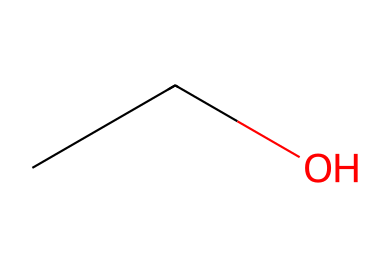How many carbon atoms are in this chemical? The SMILES representation "CCO" indicates the presence of two 'C' atoms, which are the carbon atoms in the chemical.
Answer: 2 What type of functional group is present in this chemical? The structure "CCO" shows that there is an -OH (hydroxyl) group present on one of the carbon atoms, identifying this chemical as an alcohol.
Answer: alcohol What is the molecular formula for this solvent? The representation "CCO" consists of two carbon (C), six hydrogen (H), and one oxygen (O) atom, leading to the molecular formula C2H6O.
Answer: C2H6O How many hydrogen atoms are in this chemical? The two carbon atoms in "CCO" are each bonded to sufficient hydrogen atoms, resulting in a total of six hydrogen atoms in this chemical.
Answer: 6 What is the boiling point characteristic of this type of solvent? Alcohols typically have moderate boiling points due to their hydrogen bonding capabilities, so this solvent likely has a boiling point higher than that of alkanes with similar carbon counts.
Answer: moderate Does this chemical have polar or nonpolar characteristics? The presence of the hydroxyl (-OH) group in "CCO" indicates that this solvent is polar, which affects its solubility properties.
Answer: polar 